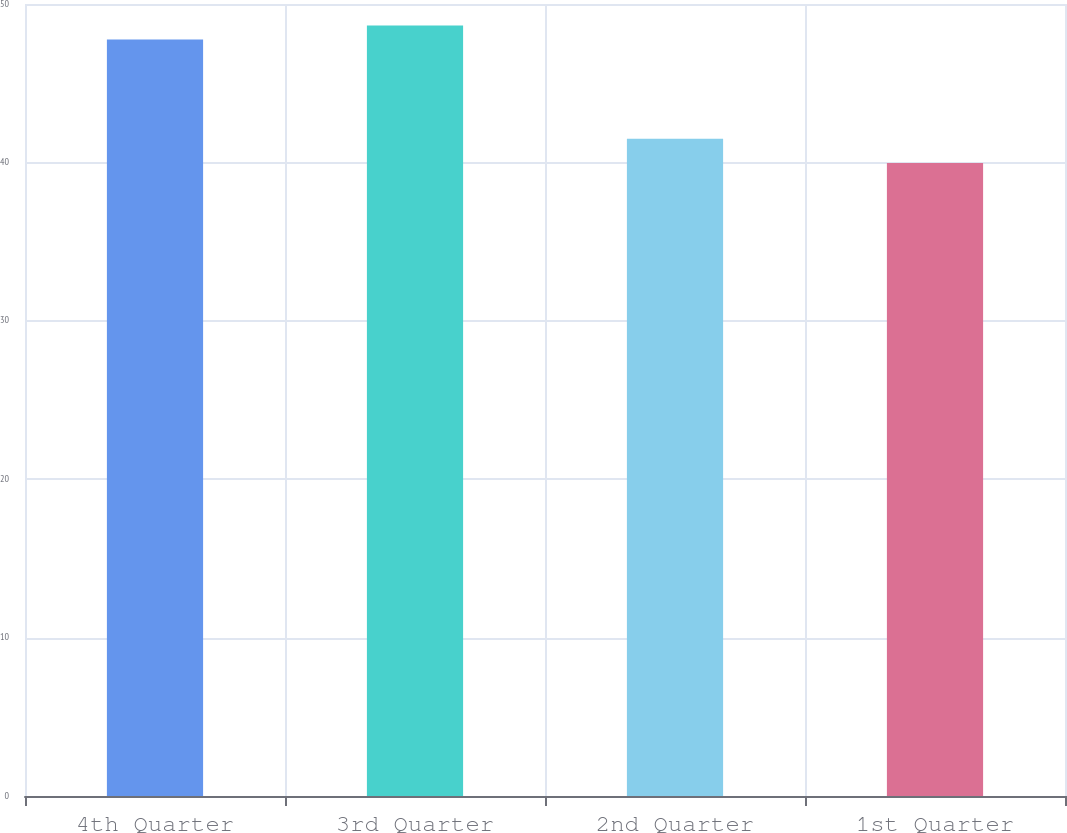Convert chart to OTSL. <chart><loc_0><loc_0><loc_500><loc_500><bar_chart><fcel>4th Quarter<fcel>3rd Quarter<fcel>2nd Quarter<fcel>1st Quarter<nl><fcel>47.76<fcel>48.64<fcel>41.49<fcel>39.97<nl></chart> 